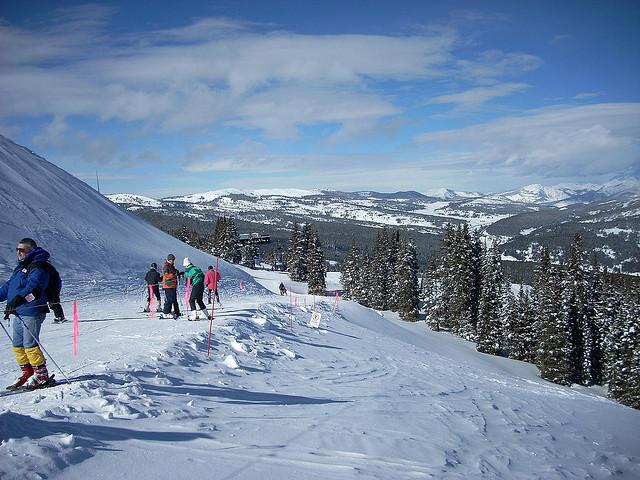Why are pink ribbons tied on the string?

Choices:
A) cancer awareness
B) wind direction
C) girl's night
D) visibility safety visibility safety 